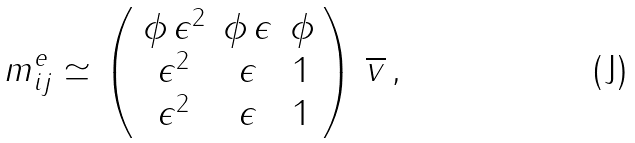Convert formula to latex. <formula><loc_0><loc_0><loc_500><loc_500>m ^ { e } _ { i j } \simeq \left ( \begin{array} { c c c } \phi \, \epsilon ^ { 2 } & \phi \, \epsilon & \phi \\ \epsilon ^ { 2 } & \epsilon & 1 \\ \epsilon ^ { 2 } & \epsilon & 1 \\ \end{array} \right ) \, \overline { v } \, ,</formula> 